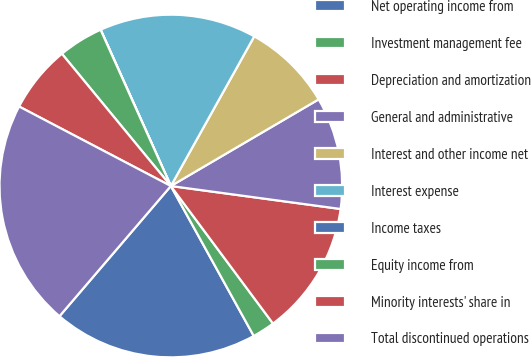Convert chart to OTSL. <chart><loc_0><loc_0><loc_500><loc_500><pie_chart><fcel>Net operating income from<fcel>Investment management fee<fcel>Depreciation and amortization<fcel>General and administrative<fcel>Interest and other income net<fcel>Interest expense<fcel>Income taxes<fcel>Equity income from<fcel>Minority interests' share in<fcel>Total discontinued operations<nl><fcel>19.3%<fcel>2.13%<fcel>12.69%<fcel>10.58%<fcel>8.47%<fcel>14.81%<fcel>0.01%<fcel>4.24%<fcel>6.35%<fcel>21.42%<nl></chart> 